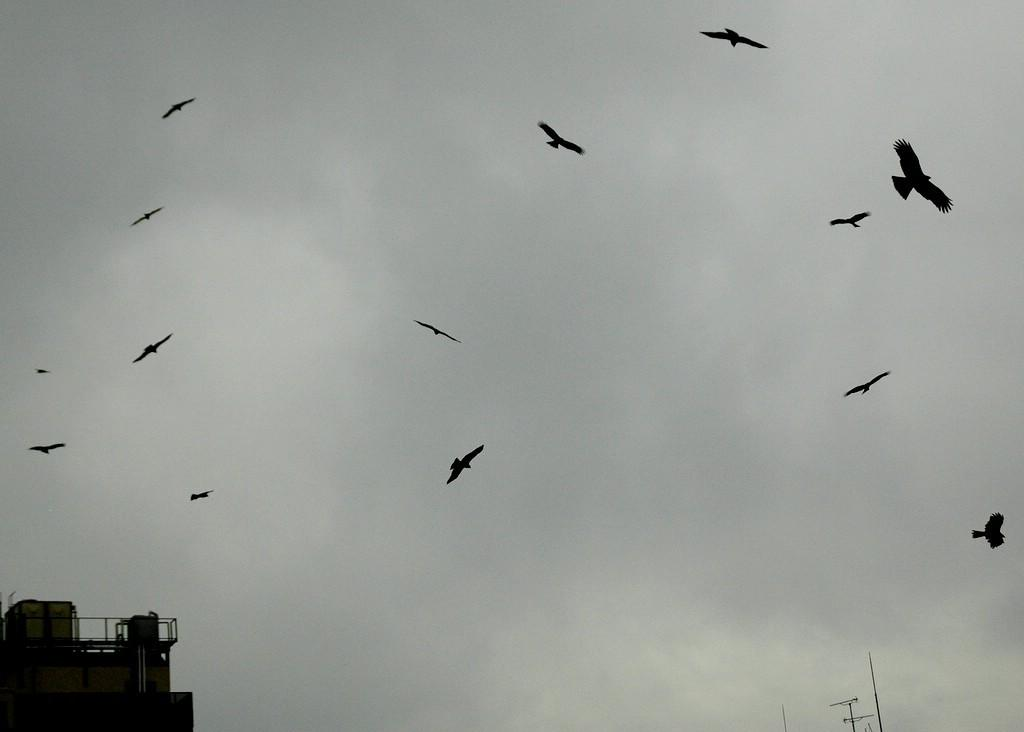What is happening in the image involving animals? There are birds flying in the image. What type of structure can be seen in the image? There is a building in the image. What are the tall, thin objects in the image? There are poles in the image. What can be seen in the background of the image? The sky with clouds is visible in the background of the image. Where is the flame coming from in the image? There is no flame present in the image. What color is the gold object in the image? There is no gold object present in the image. 